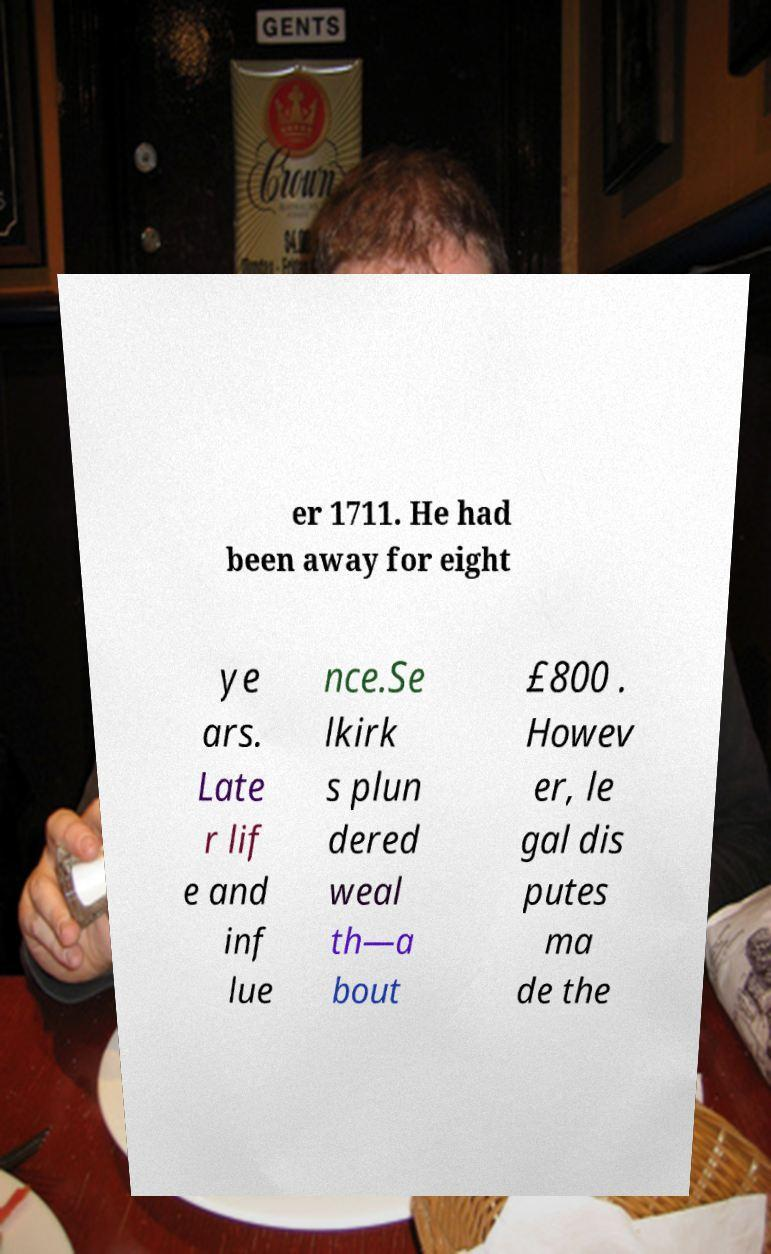For documentation purposes, I need the text within this image transcribed. Could you provide that? er 1711. He had been away for eight ye ars. Late r lif e and inf lue nce.Se lkirk s plun dered weal th—a bout £800 . Howev er, le gal dis putes ma de the 